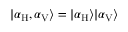<formula> <loc_0><loc_0><loc_500><loc_500>| \alpha _ { H } , \alpha _ { V } \rangle = | \alpha _ { H } \rangle | \alpha _ { V } \rangle</formula> 